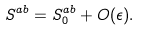<formula> <loc_0><loc_0><loc_500><loc_500>S ^ { a b } = S ^ { a b } _ { 0 } + O ( \epsilon ) .</formula> 